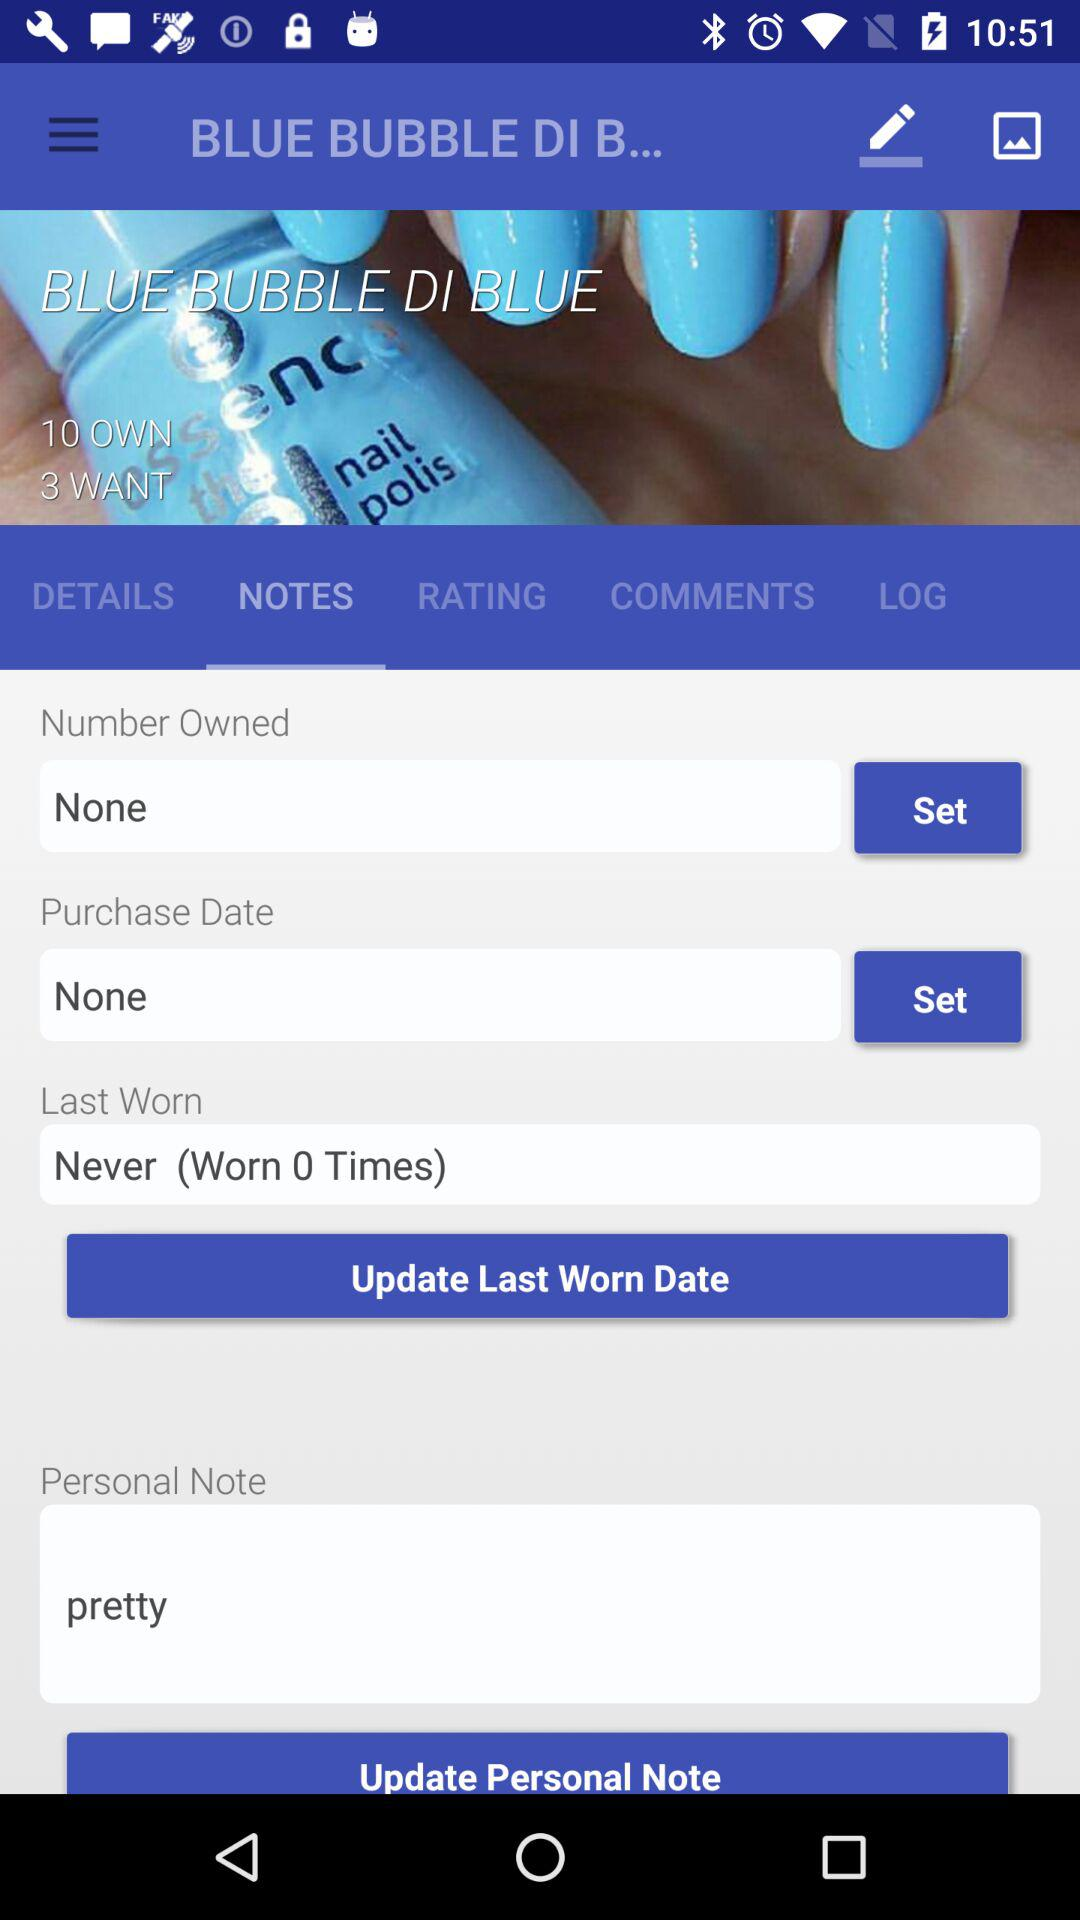What is the total number of last worn? The total number of last worn is 0. 